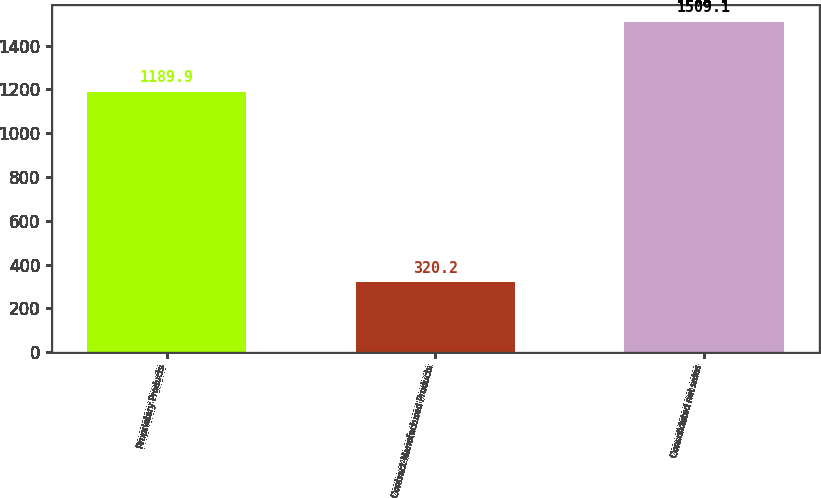<chart> <loc_0><loc_0><loc_500><loc_500><bar_chart><fcel>Proprietary Products<fcel>Contract-Manufactured Products<fcel>Consolidated net sales<nl><fcel>1189.9<fcel>320.2<fcel>1509.1<nl></chart> 